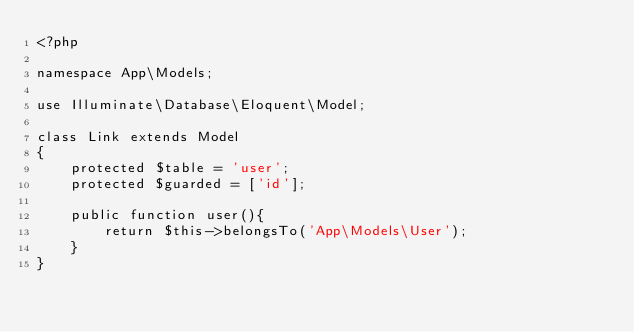Convert code to text. <code><loc_0><loc_0><loc_500><loc_500><_PHP_><?php

namespace App\Models;

use Illuminate\Database\Eloquent\Model;

class Link extends Model
{
    protected $table = 'user';
    protected $guarded = ['id'];

    public function user(){
        return $this->belongsTo('App\Models\User');
    }
}
</code> 